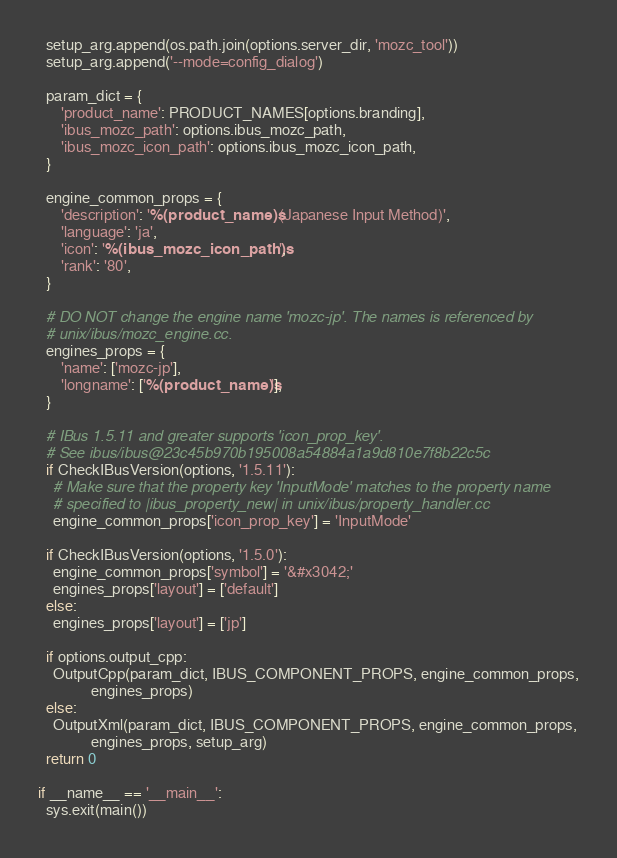Convert code to text. <code><loc_0><loc_0><loc_500><loc_500><_Python_>  setup_arg.append(os.path.join(options.server_dir, 'mozc_tool'))
  setup_arg.append('--mode=config_dialog')

  param_dict = {
      'product_name': PRODUCT_NAMES[options.branding],
      'ibus_mozc_path': options.ibus_mozc_path,
      'ibus_mozc_icon_path': options.ibus_mozc_icon_path,
  }

  engine_common_props = {
      'description': '%(product_name)s (Japanese Input Method)',
      'language': 'ja',
      'icon': '%(ibus_mozc_icon_path)s',
      'rank': '80',
  }

  # DO NOT change the engine name 'mozc-jp'. The names is referenced by
  # unix/ibus/mozc_engine.cc.
  engines_props = {
      'name': ['mozc-jp'],
      'longname': ['%(product_name)s'],
  }

  # IBus 1.5.11 and greater supports 'icon_prop_key'.
  # See ibus/ibus@23c45b970b195008a54884a1a9d810e7f8b22c5c
  if CheckIBusVersion(options, '1.5.11'):
    # Make sure that the property key 'InputMode' matches to the property name
    # specified to |ibus_property_new| in unix/ibus/property_handler.cc
    engine_common_props['icon_prop_key'] = 'InputMode'

  if CheckIBusVersion(options, '1.5.0'):
    engine_common_props['symbol'] = '&#x3042;'
    engines_props['layout'] = ['default']
  else:
    engines_props['layout'] = ['jp']

  if options.output_cpp:
    OutputCpp(param_dict, IBUS_COMPONENT_PROPS, engine_common_props,
              engines_props)
  else:
    OutputXml(param_dict, IBUS_COMPONENT_PROPS, engine_common_props,
              engines_props, setup_arg)
  return 0

if __name__ == '__main__':
  sys.exit(main())
</code> 